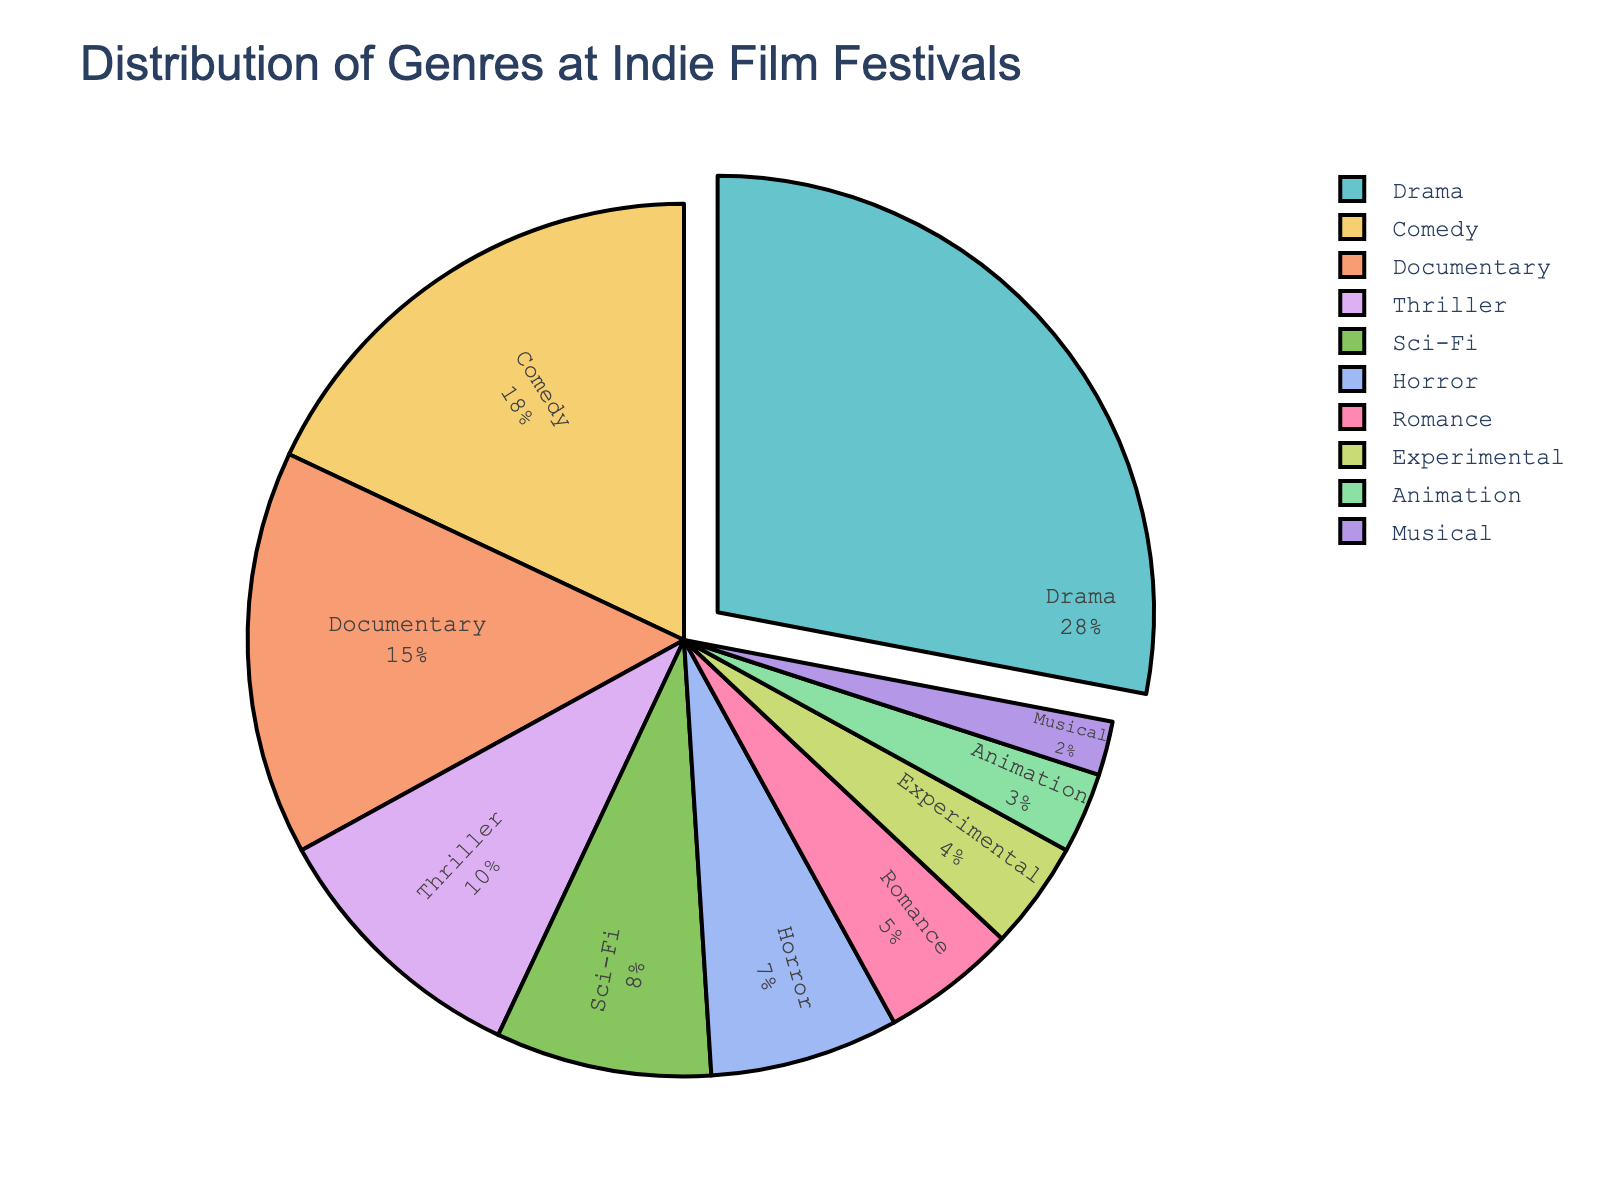What genre has the highest percentage at indie film festivals? The genre with the highest percentage is indicated by the largest section of the pie chart, as well as being pulled out slightly. This genre is Drama.
Answer: Drama What is the combined percentage of Comedy, Documentary, and Thriller genres? To find the combined percentage, add the percentage values for Comedy, Documentary, and Thriller (18 + 15 + 10).
Answer: 43 Which genre is more represented at indie film festivals: Horror or Romance? Compare the percentage values for Horror and Romance from the pie chart. Horror has 7%, while Romance has 5%, so Horror is more represented.
Answer: Horror What is the difference in percentage between Sci-Fi and Animation genres? Subtract the percentage value of Animation from Sci-Fi (8 - 3).
Answer: 5 Which genre occupies the smallest section of the pie chart? The genre with the smallest percentage will occupy the smallest section of the pie chart. This genre is Musical.
Answer: Musical How many genres have a percentage greater than 10%? Count the sections in the pie chart that represent genres with percentages higher than 10%: Drama, Comedy, and Documentary.
Answer: 3 If we combine the percentages of Thriller and Sci-Fi, would their combined percentage surpass Drama? Add the percentage values for Thriller and Sci-Fi (10 + 8) and compare the result with Drama (28). The combined percentage (18) does not surpass Drama (28).
Answer: No Are there more genres with a percentage less than 10% or more than 10%? Count the number of genres with percentages less than 10% (Sci-Fi, Horror, Romance, Experimental, Animation, Musical) and more than 10% (Drama, Comedy, Documentary). There are 6 genres with less than 10% and 3 genres with more than 10%.
Answer: Less than 10% Which genre's section is pulled out slightly from the pie chart? The section of the genre with the highest percentage (Drama) is pulled slightly out from the pie chart.
Answer: Drama What is the combined percentage of Drama and Documentary genres, and how does it compare to 50%? Add the percentage values for Drama and Documentary (28 + 15) and compare the result with 50%. The combined percentage (43) is less than 50%.
Answer: Less than 50% 